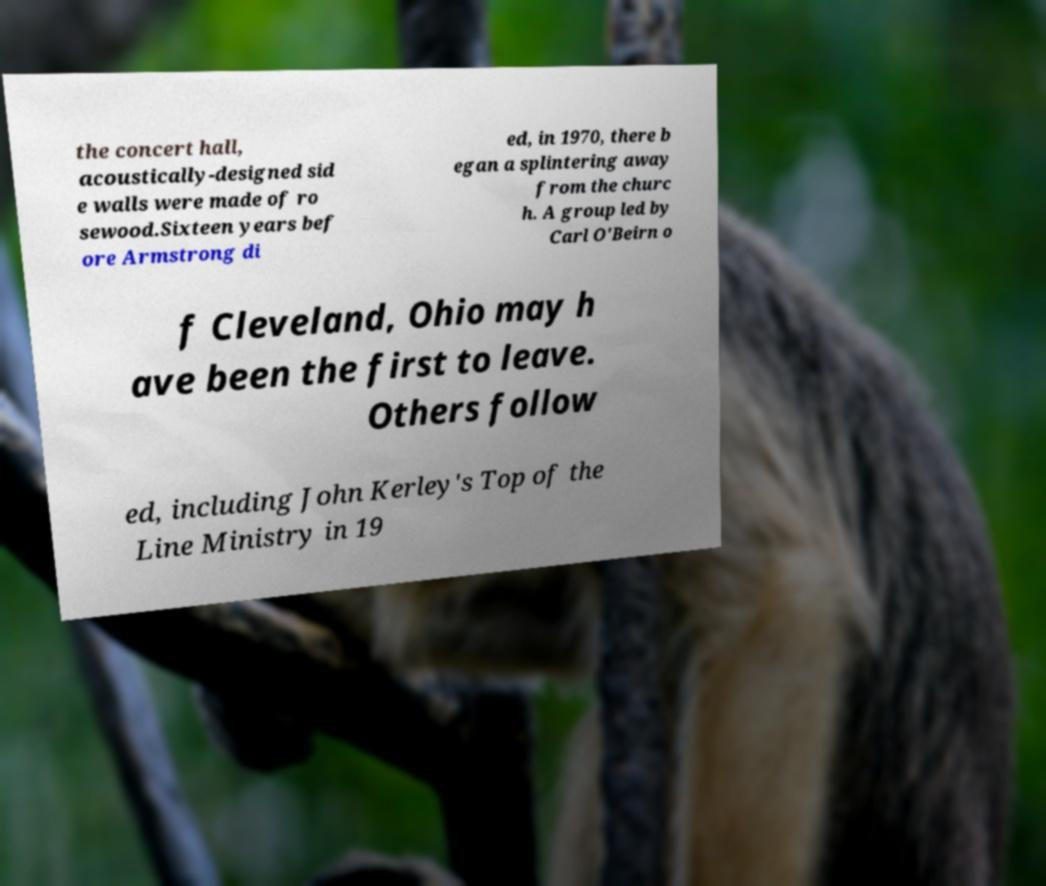There's text embedded in this image that I need extracted. Can you transcribe it verbatim? the concert hall, acoustically-designed sid e walls were made of ro sewood.Sixteen years bef ore Armstrong di ed, in 1970, there b egan a splintering away from the churc h. A group led by Carl O'Beirn o f Cleveland, Ohio may h ave been the first to leave. Others follow ed, including John Kerley's Top of the Line Ministry in 19 